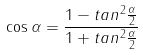Convert formula to latex. <formula><loc_0><loc_0><loc_500><loc_500>\cos \alpha = \frac { 1 - t a n ^ { 2 } \frac { \alpha } { 2 } } { 1 + t a n ^ { 2 } \frac { \alpha } { 2 } }</formula> 